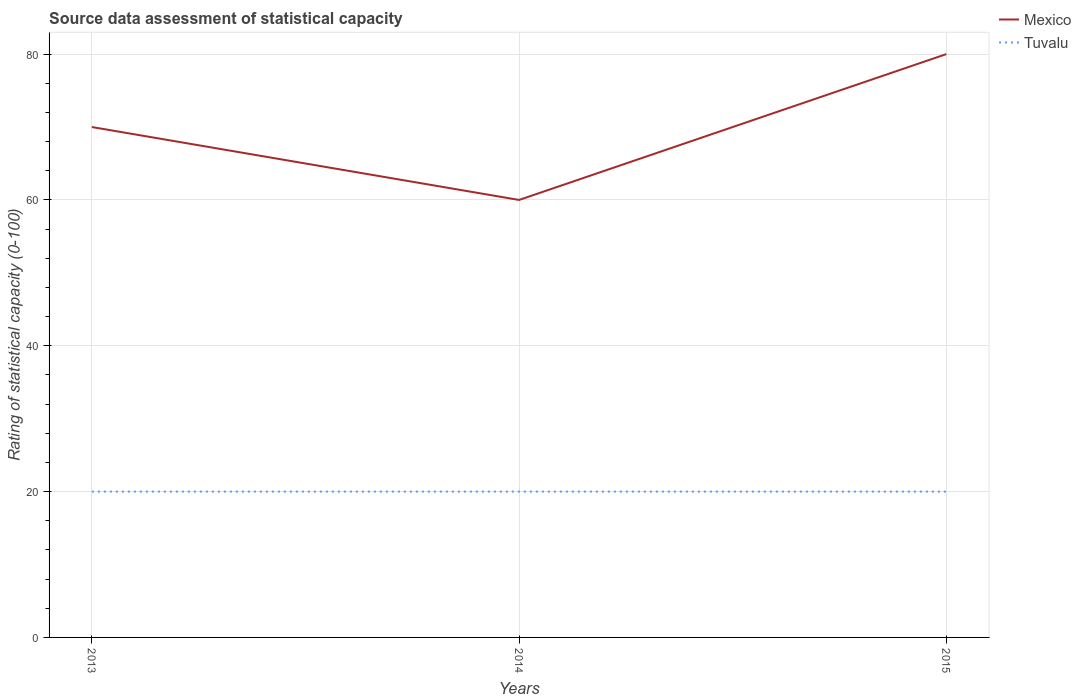How many different coloured lines are there?
Offer a terse response. 2. Is the number of lines equal to the number of legend labels?
Your response must be concise. Yes. In which year was the rating of statistical capacity in Mexico maximum?
Your answer should be compact. 2014. What is the difference between the highest and the second highest rating of statistical capacity in Mexico?
Offer a terse response. 20. What is the difference between the highest and the lowest rating of statistical capacity in Mexico?
Give a very brief answer. 1. Is the rating of statistical capacity in Tuvalu strictly greater than the rating of statistical capacity in Mexico over the years?
Offer a very short reply. Yes. How many years are there in the graph?
Ensure brevity in your answer.  3. Does the graph contain any zero values?
Ensure brevity in your answer.  No. Does the graph contain grids?
Keep it short and to the point. Yes. How many legend labels are there?
Your answer should be compact. 2. What is the title of the graph?
Your answer should be compact. Source data assessment of statistical capacity. Does "Fiji" appear as one of the legend labels in the graph?
Provide a succinct answer. No. What is the label or title of the Y-axis?
Your answer should be very brief. Rating of statistical capacity (0-100). What is the Rating of statistical capacity (0-100) of Mexico in 2013?
Offer a terse response. 70. What is the Rating of statistical capacity (0-100) in Mexico in 2014?
Ensure brevity in your answer.  60. What is the Rating of statistical capacity (0-100) of Tuvalu in 2015?
Keep it short and to the point. 20. Across all years, what is the maximum Rating of statistical capacity (0-100) in Tuvalu?
Keep it short and to the point. 20. Across all years, what is the minimum Rating of statistical capacity (0-100) in Mexico?
Your answer should be very brief. 60. What is the total Rating of statistical capacity (0-100) in Mexico in the graph?
Provide a succinct answer. 210. What is the difference between the Rating of statistical capacity (0-100) of Tuvalu in 2013 and that in 2014?
Provide a succinct answer. 0. What is the difference between the Rating of statistical capacity (0-100) in Mexico in 2013 and that in 2015?
Keep it short and to the point. -10. What is the difference between the Rating of statistical capacity (0-100) in Mexico in 2014 and that in 2015?
Your answer should be very brief. -20. What is the difference between the Rating of statistical capacity (0-100) of Tuvalu in 2014 and that in 2015?
Keep it short and to the point. 0. What is the difference between the Rating of statistical capacity (0-100) of Mexico in 2013 and the Rating of statistical capacity (0-100) of Tuvalu in 2014?
Provide a succinct answer. 50. What is the difference between the Rating of statistical capacity (0-100) of Mexico in 2014 and the Rating of statistical capacity (0-100) of Tuvalu in 2015?
Your answer should be very brief. 40. What is the average Rating of statistical capacity (0-100) in Mexico per year?
Your answer should be very brief. 70. What is the average Rating of statistical capacity (0-100) in Tuvalu per year?
Ensure brevity in your answer.  20. In the year 2013, what is the difference between the Rating of statistical capacity (0-100) of Mexico and Rating of statistical capacity (0-100) of Tuvalu?
Your answer should be compact. 50. What is the ratio of the Rating of statistical capacity (0-100) in Tuvalu in 2013 to that in 2014?
Your answer should be compact. 1. What is the ratio of the Rating of statistical capacity (0-100) in Mexico in 2013 to that in 2015?
Offer a very short reply. 0.88. What is the ratio of the Rating of statistical capacity (0-100) in Tuvalu in 2014 to that in 2015?
Your answer should be very brief. 1. What is the difference between the highest and the lowest Rating of statistical capacity (0-100) of Tuvalu?
Make the answer very short. 0. 